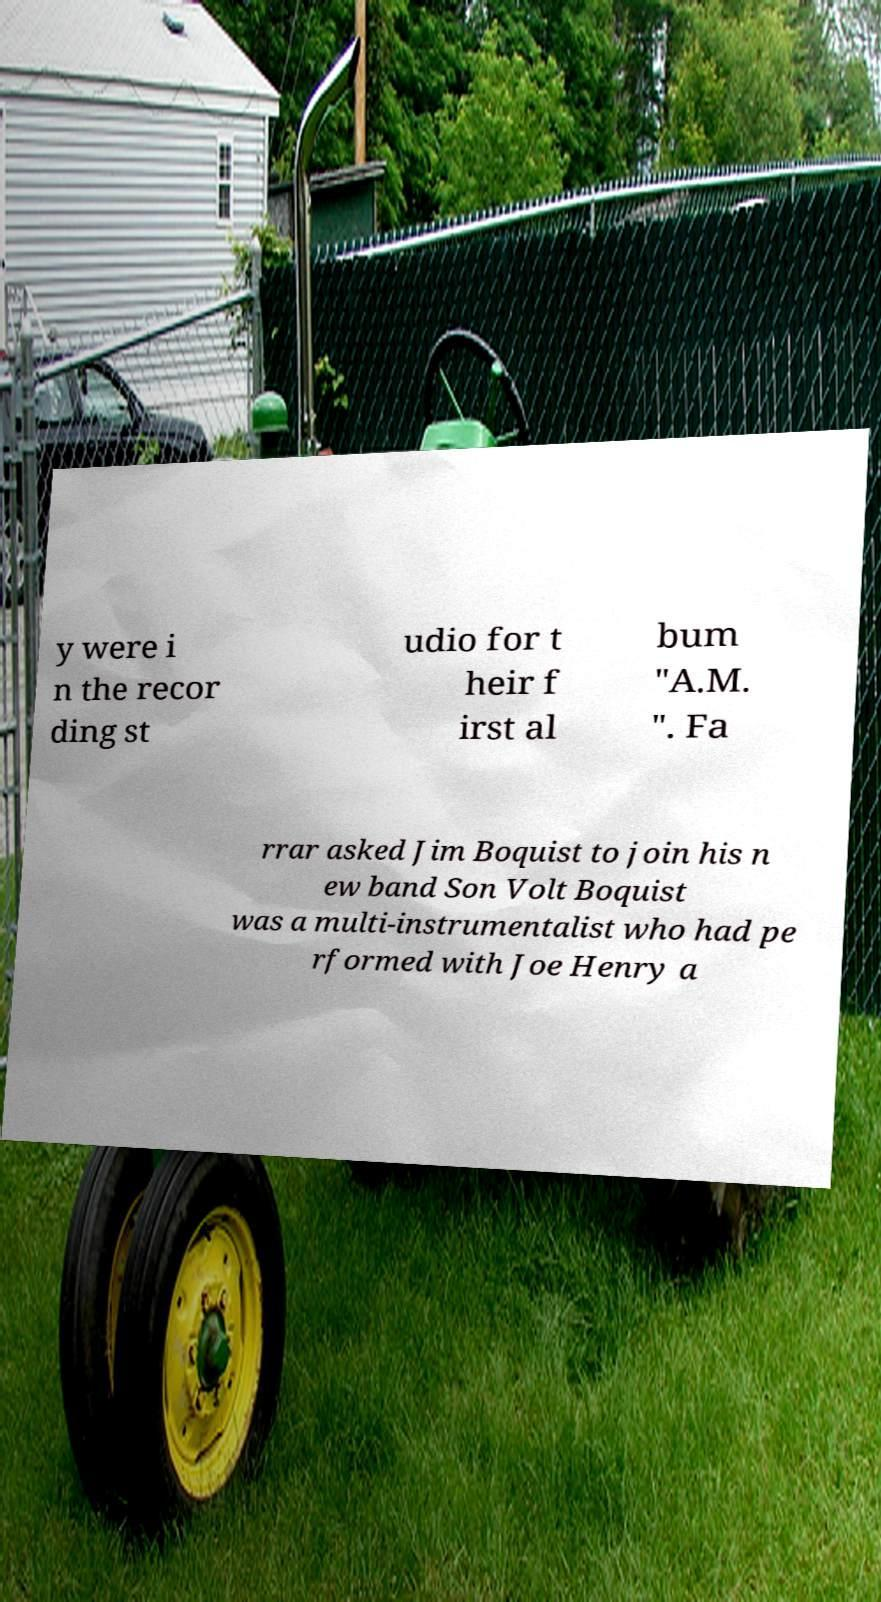What messages or text are displayed in this image? I need them in a readable, typed format. y were i n the recor ding st udio for t heir f irst al bum "A.M. ". Fa rrar asked Jim Boquist to join his n ew band Son Volt Boquist was a multi-instrumentalist who had pe rformed with Joe Henry a 